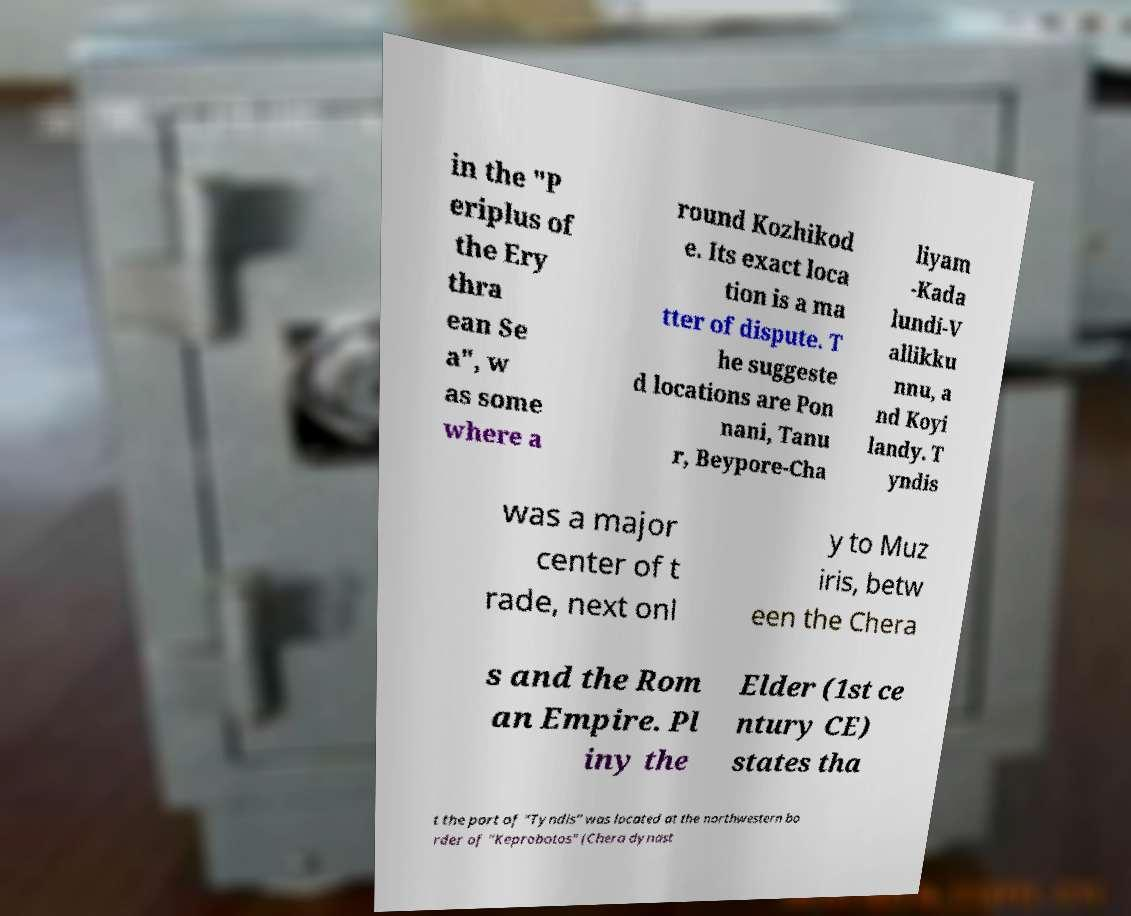For documentation purposes, I need the text within this image transcribed. Could you provide that? in the "P eriplus of the Ery thra ean Se a", w as some where a round Kozhikod e. Its exact loca tion is a ma tter of dispute. T he suggeste d locations are Pon nani, Tanu r, Beypore-Cha liyam -Kada lundi-V allikku nnu, a nd Koyi landy. T yndis was a major center of t rade, next onl y to Muz iris, betw een the Chera s and the Rom an Empire. Pl iny the Elder (1st ce ntury CE) states tha t the port of "Tyndis" was located at the northwestern bo rder of "Keprobotos" (Chera dynast 